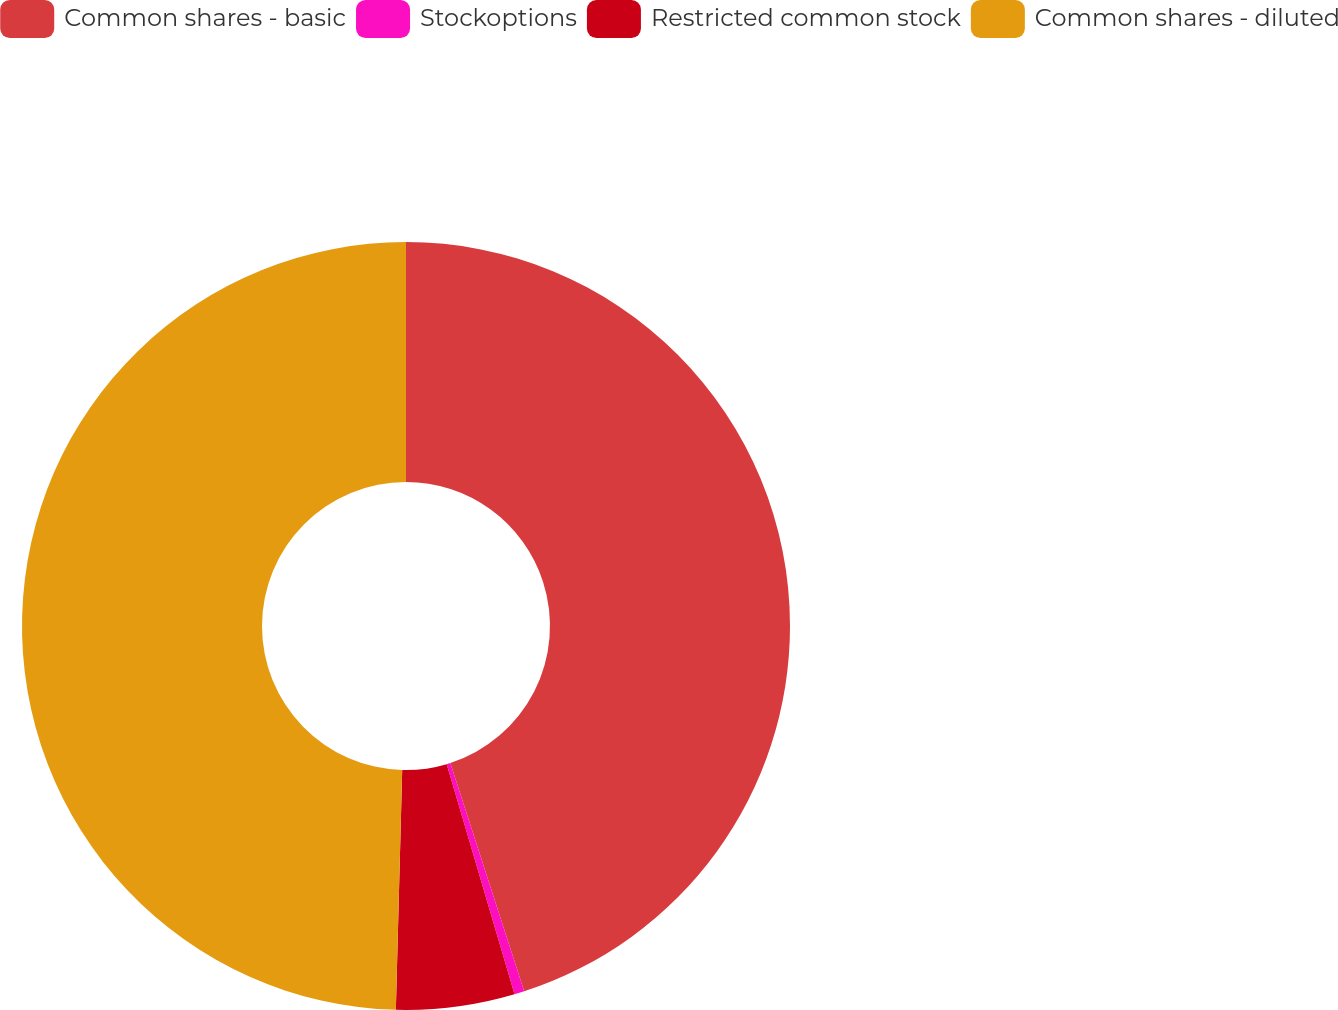Convert chart. <chart><loc_0><loc_0><loc_500><loc_500><pie_chart><fcel>Common shares - basic<fcel>Stockoptions<fcel>Restricted common stock<fcel>Common shares - diluted<nl><fcel>45.02%<fcel>0.42%<fcel>4.98%<fcel>49.58%<nl></chart> 